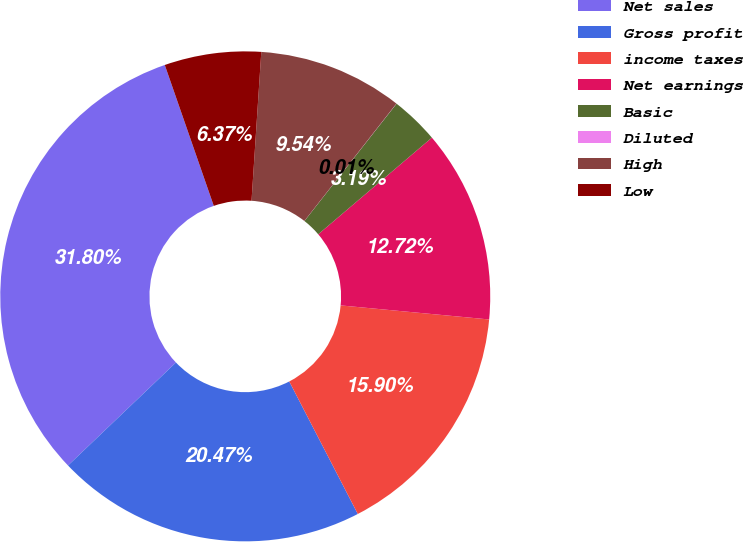<chart> <loc_0><loc_0><loc_500><loc_500><pie_chart><fcel>Net sales<fcel>Gross profit<fcel>income taxes<fcel>Net earnings<fcel>Basic<fcel>Diluted<fcel>High<fcel>Low<nl><fcel>31.8%<fcel>20.47%<fcel>15.9%<fcel>12.72%<fcel>3.19%<fcel>0.01%<fcel>9.54%<fcel>6.37%<nl></chart> 